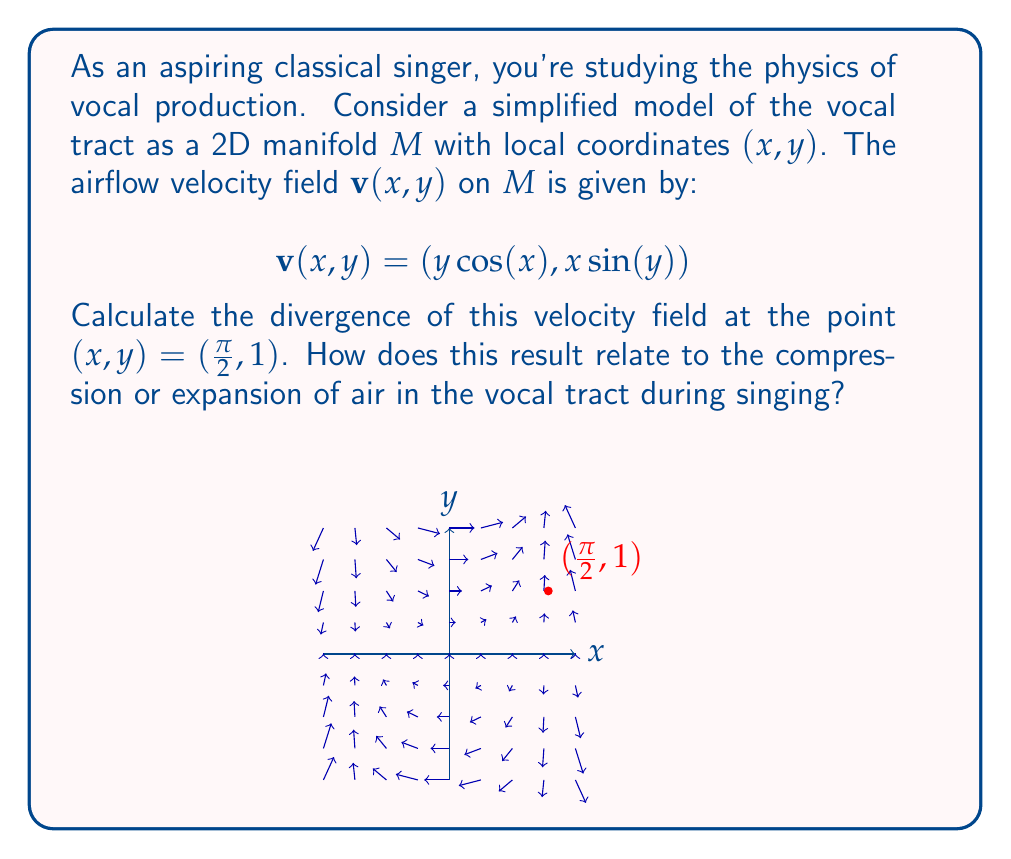Show me your answer to this math problem. Let's approach this step-by-step:

1) The divergence of a vector field $\mathbf{v}(x, y) = (v_x, v_y)$ on a 2D manifold is given by:

   $$\text{div}\,\mathbf{v} = \frac{\partial v_x}{\partial x} + \frac{\partial v_y}{\partial y}$$

2) In our case, $v_x = y\cos(x)$ and $v_y = x\sin(y)$. Let's calculate the partial derivatives:

   $$\frac{\partial v_x}{\partial x} = -y\sin(x)$$
   $$\frac{\partial v_y}{\partial y} = x\cos(y)$$

3) Now, we can write the divergence as:

   $$\text{div}\,\mathbf{v} = -y\sin(x) + x\cos(y)$$

4) We need to evaluate this at the point $(\frac{\pi}{2}, 1)$. Let's substitute these values:

   $$\text{div}\,\mathbf{v}(\frac{\pi}{2}, 1) = -(1)\sin(\frac{\pi}{2}) + (\frac{\pi}{2})\cos(1)$$

5) Simplify:
   $$\text{div}\,\mathbf{v}(\frac{\pi}{2}, 1) = -1 + \frac{\pi}{2}\cos(1)$$

6) This result relates to the compression or expansion of air in the vocal tract during singing as follows:
   - If the divergence is positive, it indicates expansion of the air.
   - If the divergence is negative, it indicates compression of the air.
   - If the divergence is zero, it indicates neither compression nor expansion.

   In this case, the result is approximately 0.0708, which is slightly positive, indicating a small expansion of air at this point in the vocal tract.
Answer: $-1 + \frac{\pi}{2}\cos(1) \approx 0.0708$ 